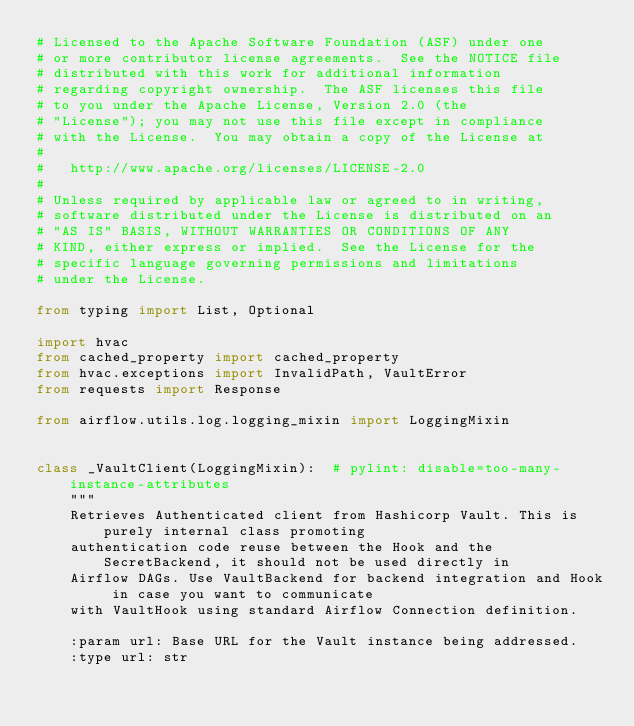<code> <loc_0><loc_0><loc_500><loc_500><_Python_># Licensed to the Apache Software Foundation (ASF) under one
# or more contributor license agreements.  See the NOTICE file
# distributed with this work for additional information
# regarding copyright ownership.  The ASF licenses this file
# to you under the Apache License, Version 2.0 (the
# "License"); you may not use this file except in compliance
# with the License.  You may obtain a copy of the License at
#
#   http://www.apache.org/licenses/LICENSE-2.0
#
# Unless required by applicable law or agreed to in writing,
# software distributed under the License is distributed on an
# "AS IS" BASIS, WITHOUT WARRANTIES OR CONDITIONS OF ANY
# KIND, either express or implied.  See the License for the
# specific language governing permissions and limitations
# under the License.

from typing import List, Optional

import hvac
from cached_property import cached_property
from hvac.exceptions import InvalidPath, VaultError
from requests import Response

from airflow.utils.log.logging_mixin import LoggingMixin


class _VaultClient(LoggingMixin):  # pylint: disable=too-many-instance-attributes
    """
    Retrieves Authenticated client from Hashicorp Vault. This is purely internal class promoting
    authentication code reuse between the Hook and the SecretBackend, it should not be used directly in
    Airflow DAGs. Use VaultBackend for backend integration and Hook in case you want to communicate
    with VaultHook using standard Airflow Connection definition.

    :param url: Base URL for the Vault instance being addressed.
    :type url: str</code> 